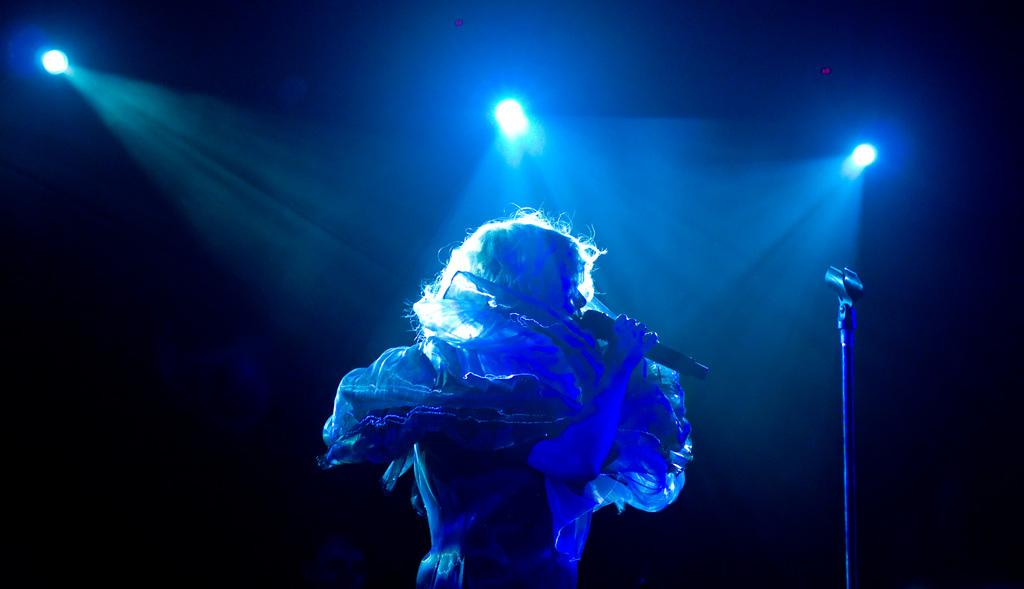What is the person in the image doing? The person is standing in the image and holding a microphone. What can be seen on the right side of the image? There is a stand on the right side of the image. What type of lighting is present in the image? Focus lights are present in the image. How would you describe the background of the image? The background of the image is dark. What type of distribution apparatus can be seen in the image? There is no distribution apparatus present in the image. Can you describe the truck that is parked in the background of the image? There is no truck present in the image; the background is dark. 